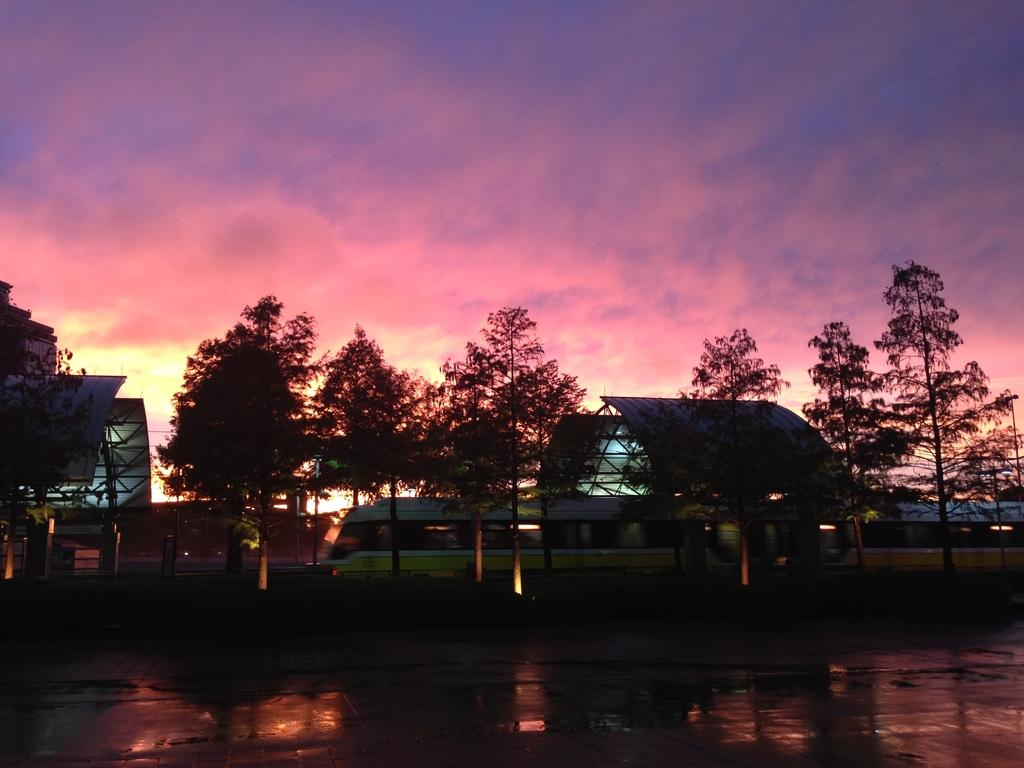What is the main feature of the image? The center of the image contains the sky. What can be seen in the sky? Clouds are visible in the sky. What type of natural vegetation is present in the image? Trees are present in the image. What mode of transportation can be seen in the image? There is a train in the image. Are there any other objects or features in the image besides the sky, clouds, trees, and train? Yes, there are a few other objects in the image. What type of breakfast is being served on the train in the image? There is no indication of breakfast being served on the train in the image. Is the stomach visible in the image? No, the stomach is not visible in the image. 